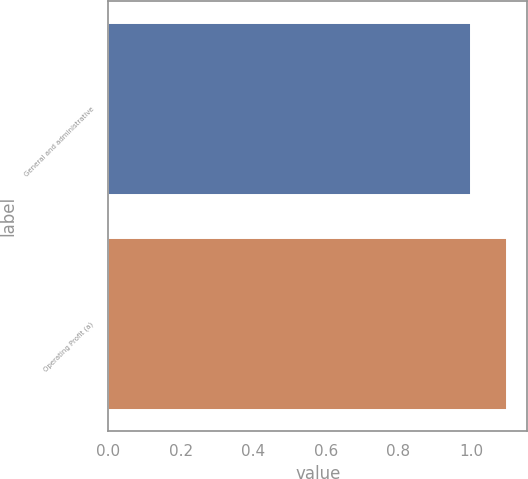Convert chart. <chart><loc_0><loc_0><loc_500><loc_500><bar_chart><fcel>General and administrative<fcel>Operating Profit (a)<nl><fcel>1<fcel>1.1<nl></chart> 